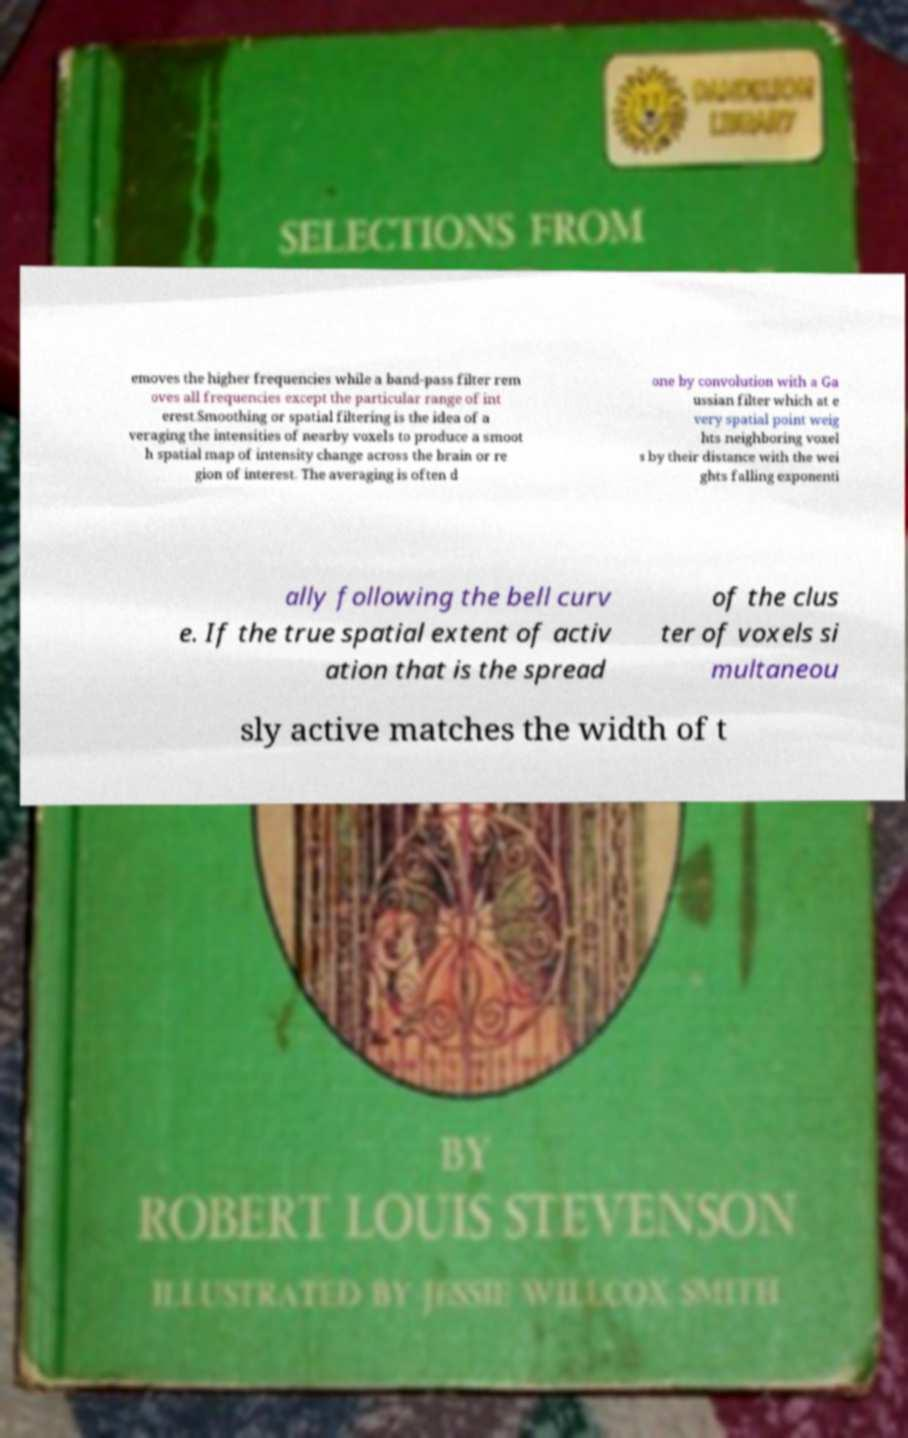What messages or text are displayed in this image? I need them in a readable, typed format. emoves the higher frequencies while a band-pass filter rem oves all frequencies except the particular range of int erest.Smoothing or spatial filtering is the idea of a veraging the intensities of nearby voxels to produce a smoot h spatial map of intensity change across the brain or re gion of interest. The averaging is often d one by convolution with a Ga ussian filter which at e very spatial point weig hts neighboring voxel s by their distance with the wei ghts falling exponenti ally following the bell curv e. If the true spatial extent of activ ation that is the spread of the clus ter of voxels si multaneou sly active matches the width of t 